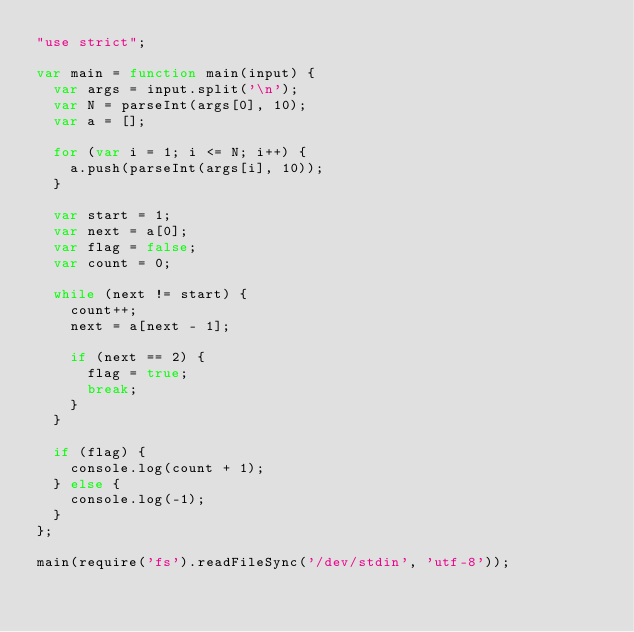Convert code to text. <code><loc_0><loc_0><loc_500><loc_500><_JavaScript_>"use strict";

var main = function main(input) {
  var args = input.split('\n');
  var N = parseInt(args[0], 10);
  var a = [];

  for (var i = 1; i <= N; i++) {
    a.push(parseInt(args[i], 10));
  }

  var start = 1;
  var next = a[0];
  var flag = false;
  var count = 0;

  while (next != start) {
    count++;
    next = a[next - 1];

    if (next == 2) {
      flag = true;
      break;
    }
  }

  if (flag) {
    console.log(count + 1);
  } else {
    console.log(-1);
  }
};

main(require('fs').readFileSync('/dev/stdin', 'utf-8'));</code> 